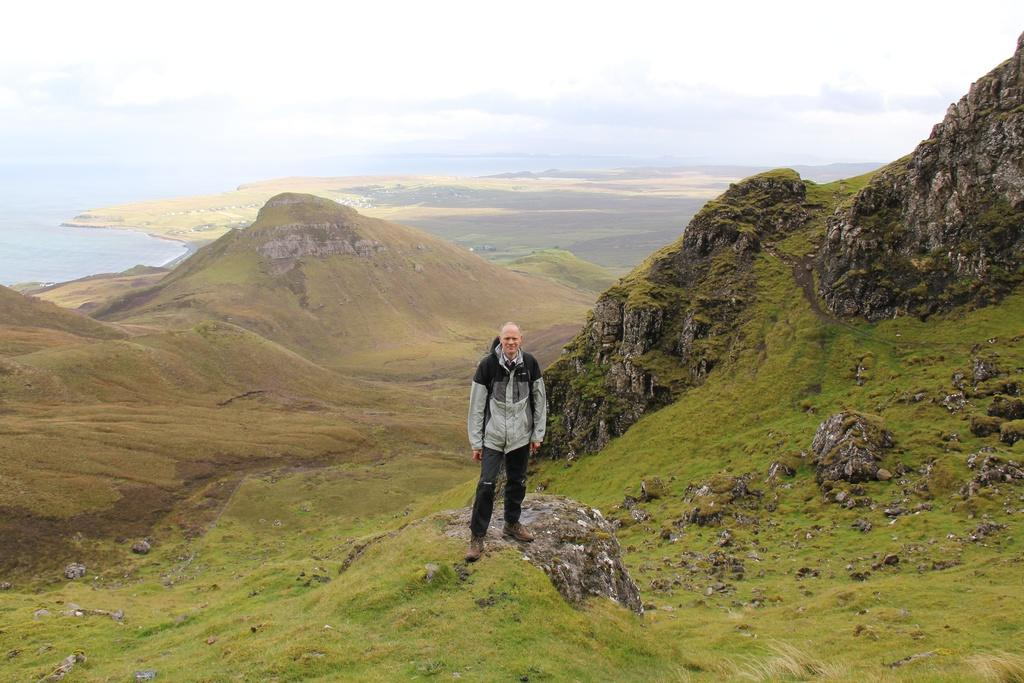What is the main subject of the image? There is a man standing in the image. Where is the man standing? The man is standing on a hill surface. What can be seen in the background of the image? Hills, a water surface, and the sky are visible in the background of the image. What is the condition of the sky in the image? Clouds are present in the sky. What type of cloth is the man using to catch the ball in the image? There is no ball or cloth present in the image; it only features a man standing on a hill with a background of hills, water, and sky. 